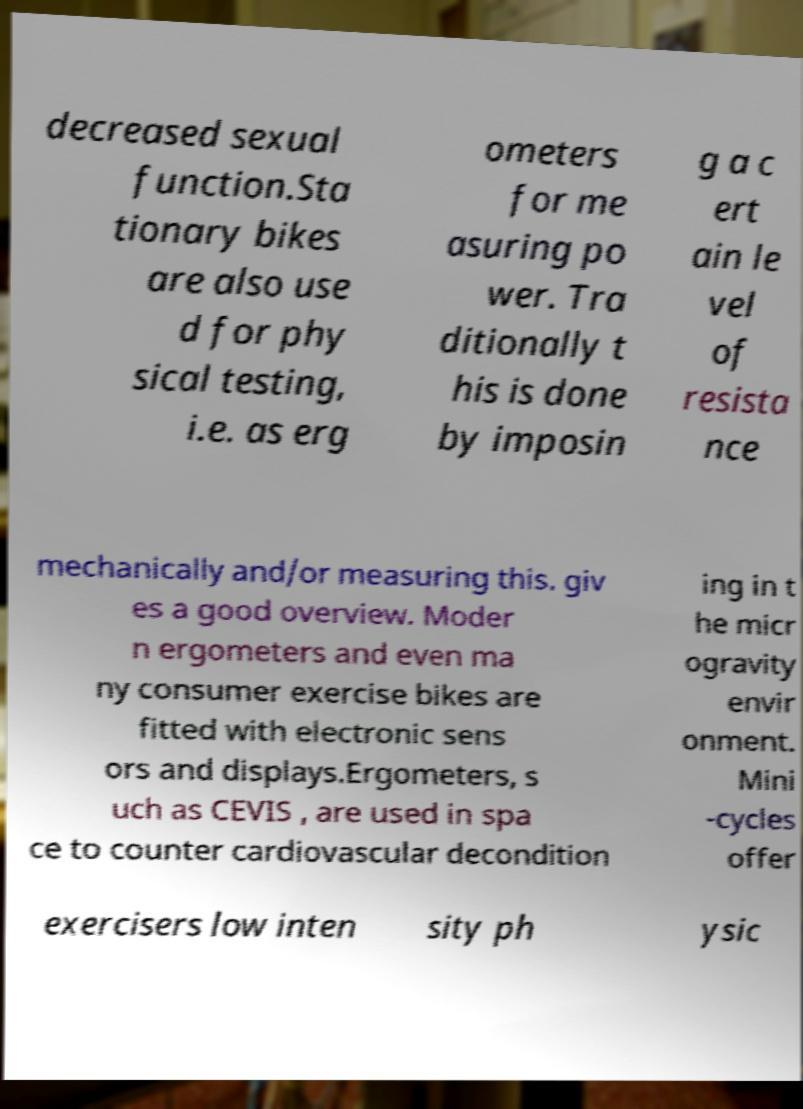Can you accurately transcribe the text from the provided image for me? decreased sexual function.Sta tionary bikes are also use d for phy sical testing, i.e. as erg ometers for me asuring po wer. Tra ditionally t his is done by imposin g a c ert ain le vel of resista nce mechanically and/or measuring this. giv es a good overview. Moder n ergometers and even ma ny consumer exercise bikes are fitted with electronic sens ors and displays.Ergometers, s uch as CEVIS , are used in spa ce to counter cardiovascular decondition ing in t he micr ogravity envir onment. Mini -cycles offer exercisers low inten sity ph ysic 